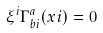<formula> <loc_0><loc_0><loc_500><loc_500>\xi ^ { i } \Gamma ^ { a } _ { b i } ( x i ) = 0</formula> 